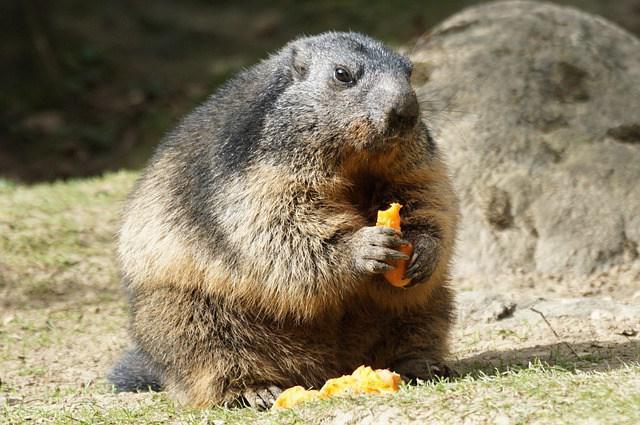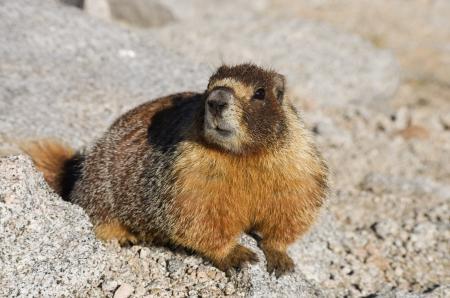The first image is the image on the left, the second image is the image on the right. Given the left and right images, does the statement "The left and right image contains the same number of groundhogs with at least one eating." hold true? Answer yes or no. Yes. The first image is the image on the left, the second image is the image on the right. Analyze the images presented: Is the assertion "The left image includes at least one marmot standing on its hind legs and clutching a piece of food near its mouth with both front paws." valid? Answer yes or no. Yes. 